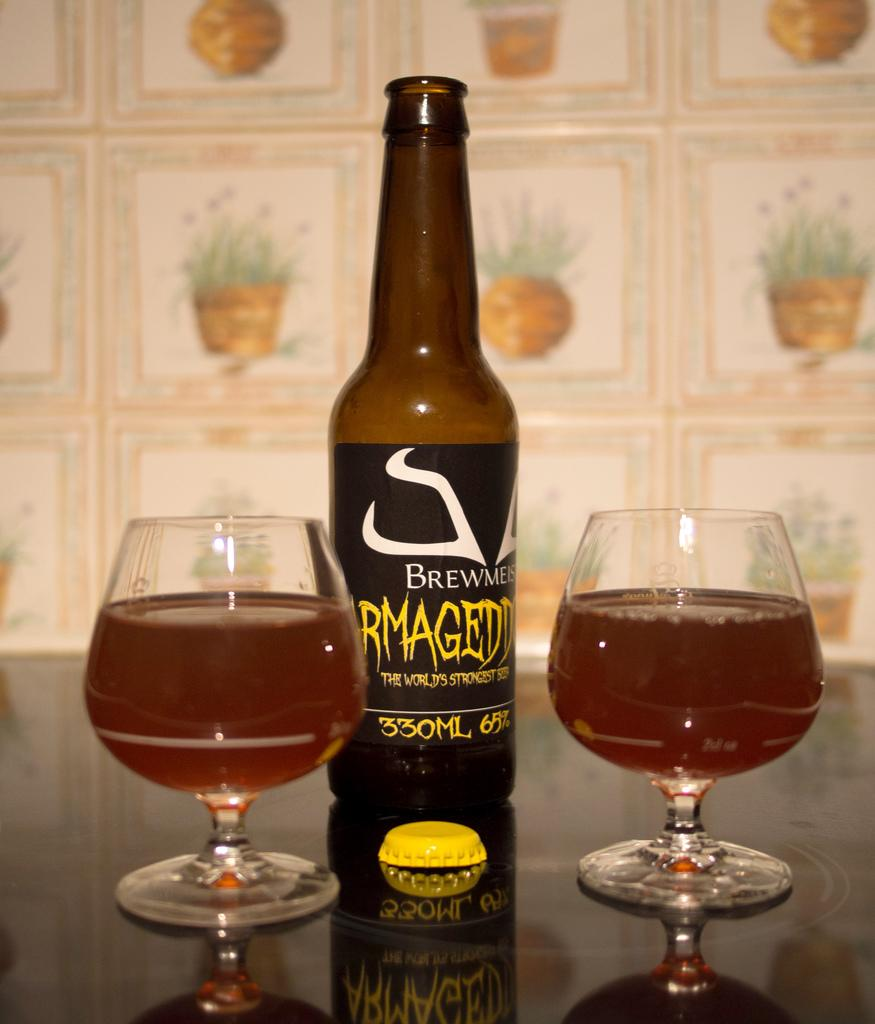What is the main object in the image? There is a wine bottle in the image. What else can be seen on the table in the image? There are two glasses on the table in the image. How many fingers are visible in the image? There are no fingers visible in the image. What type of education is being offered in the image? There is no indication of education in the image. 